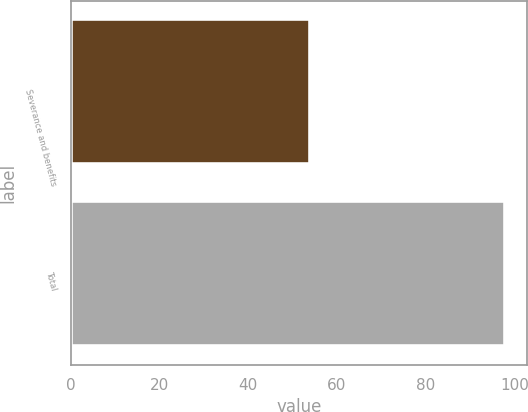<chart> <loc_0><loc_0><loc_500><loc_500><bar_chart><fcel>Severance and benefits<fcel>Total<nl><fcel>54<fcel>98<nl></chart> 